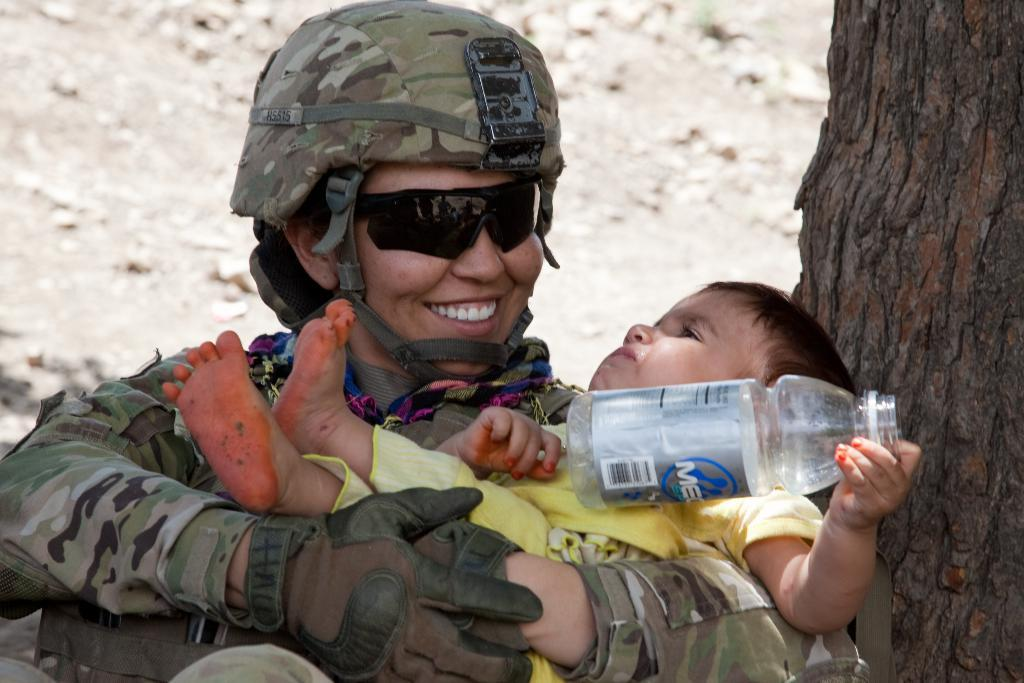What is the main subject of the image? The main subject of the image is a woman. What is the woman wearing in the image? The woman is wearing a uniform and a cap in the image. What accessory is the woman wearing in the image? The woman is wearing glasses in the image. What is the woman doing in the image? The woman is holding a baby with her hands in the image. What is the baby doing in the image? The baby is holding a bottle in the image. What is located beside the baby in the image? There is a tree beside the baby in the image. What type of calculator can be seen in the image? There is no calculator present in the image. Are there any boats visible in the image? There are no boats visible in the image. 